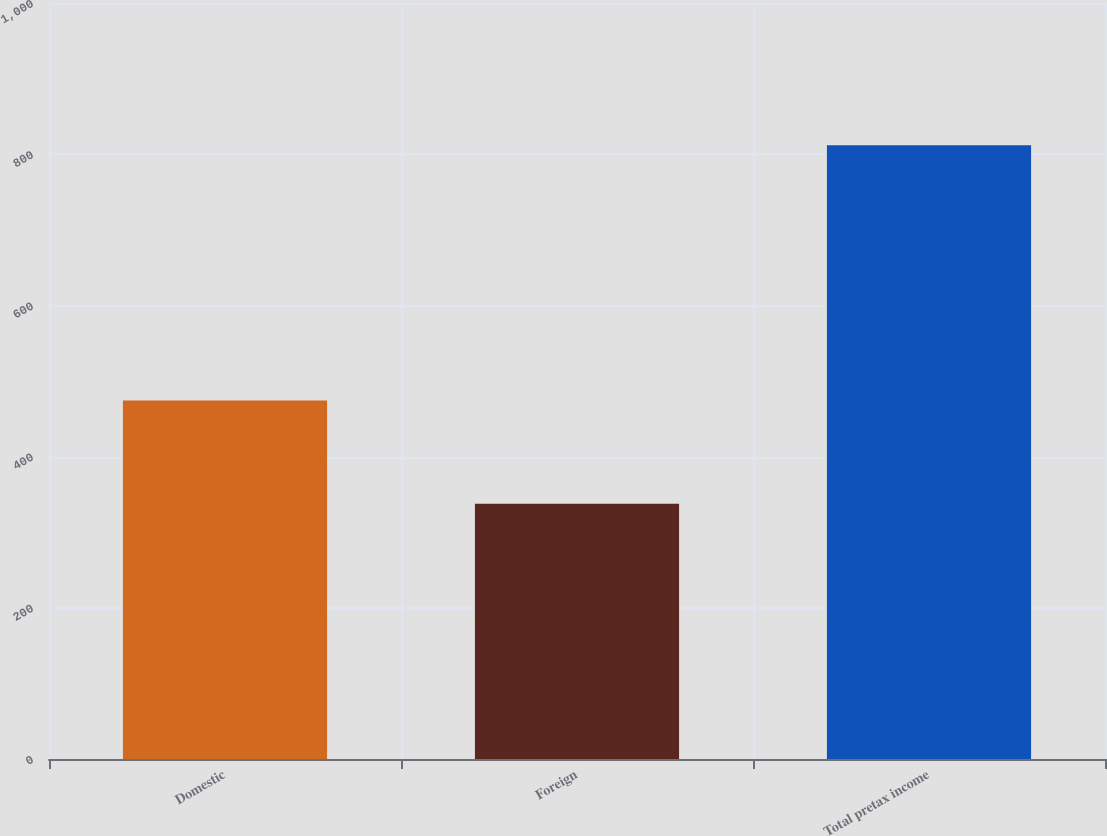Convert chart. <chart><loc_0><loc_0><loc_500><loc_500><bar_chart><fcel>Domestic<fcel>Foreign<fcel>Total pretax income<nl><fcel>474.2<fcel>337.6<fcel>811.8<nl></chart> 